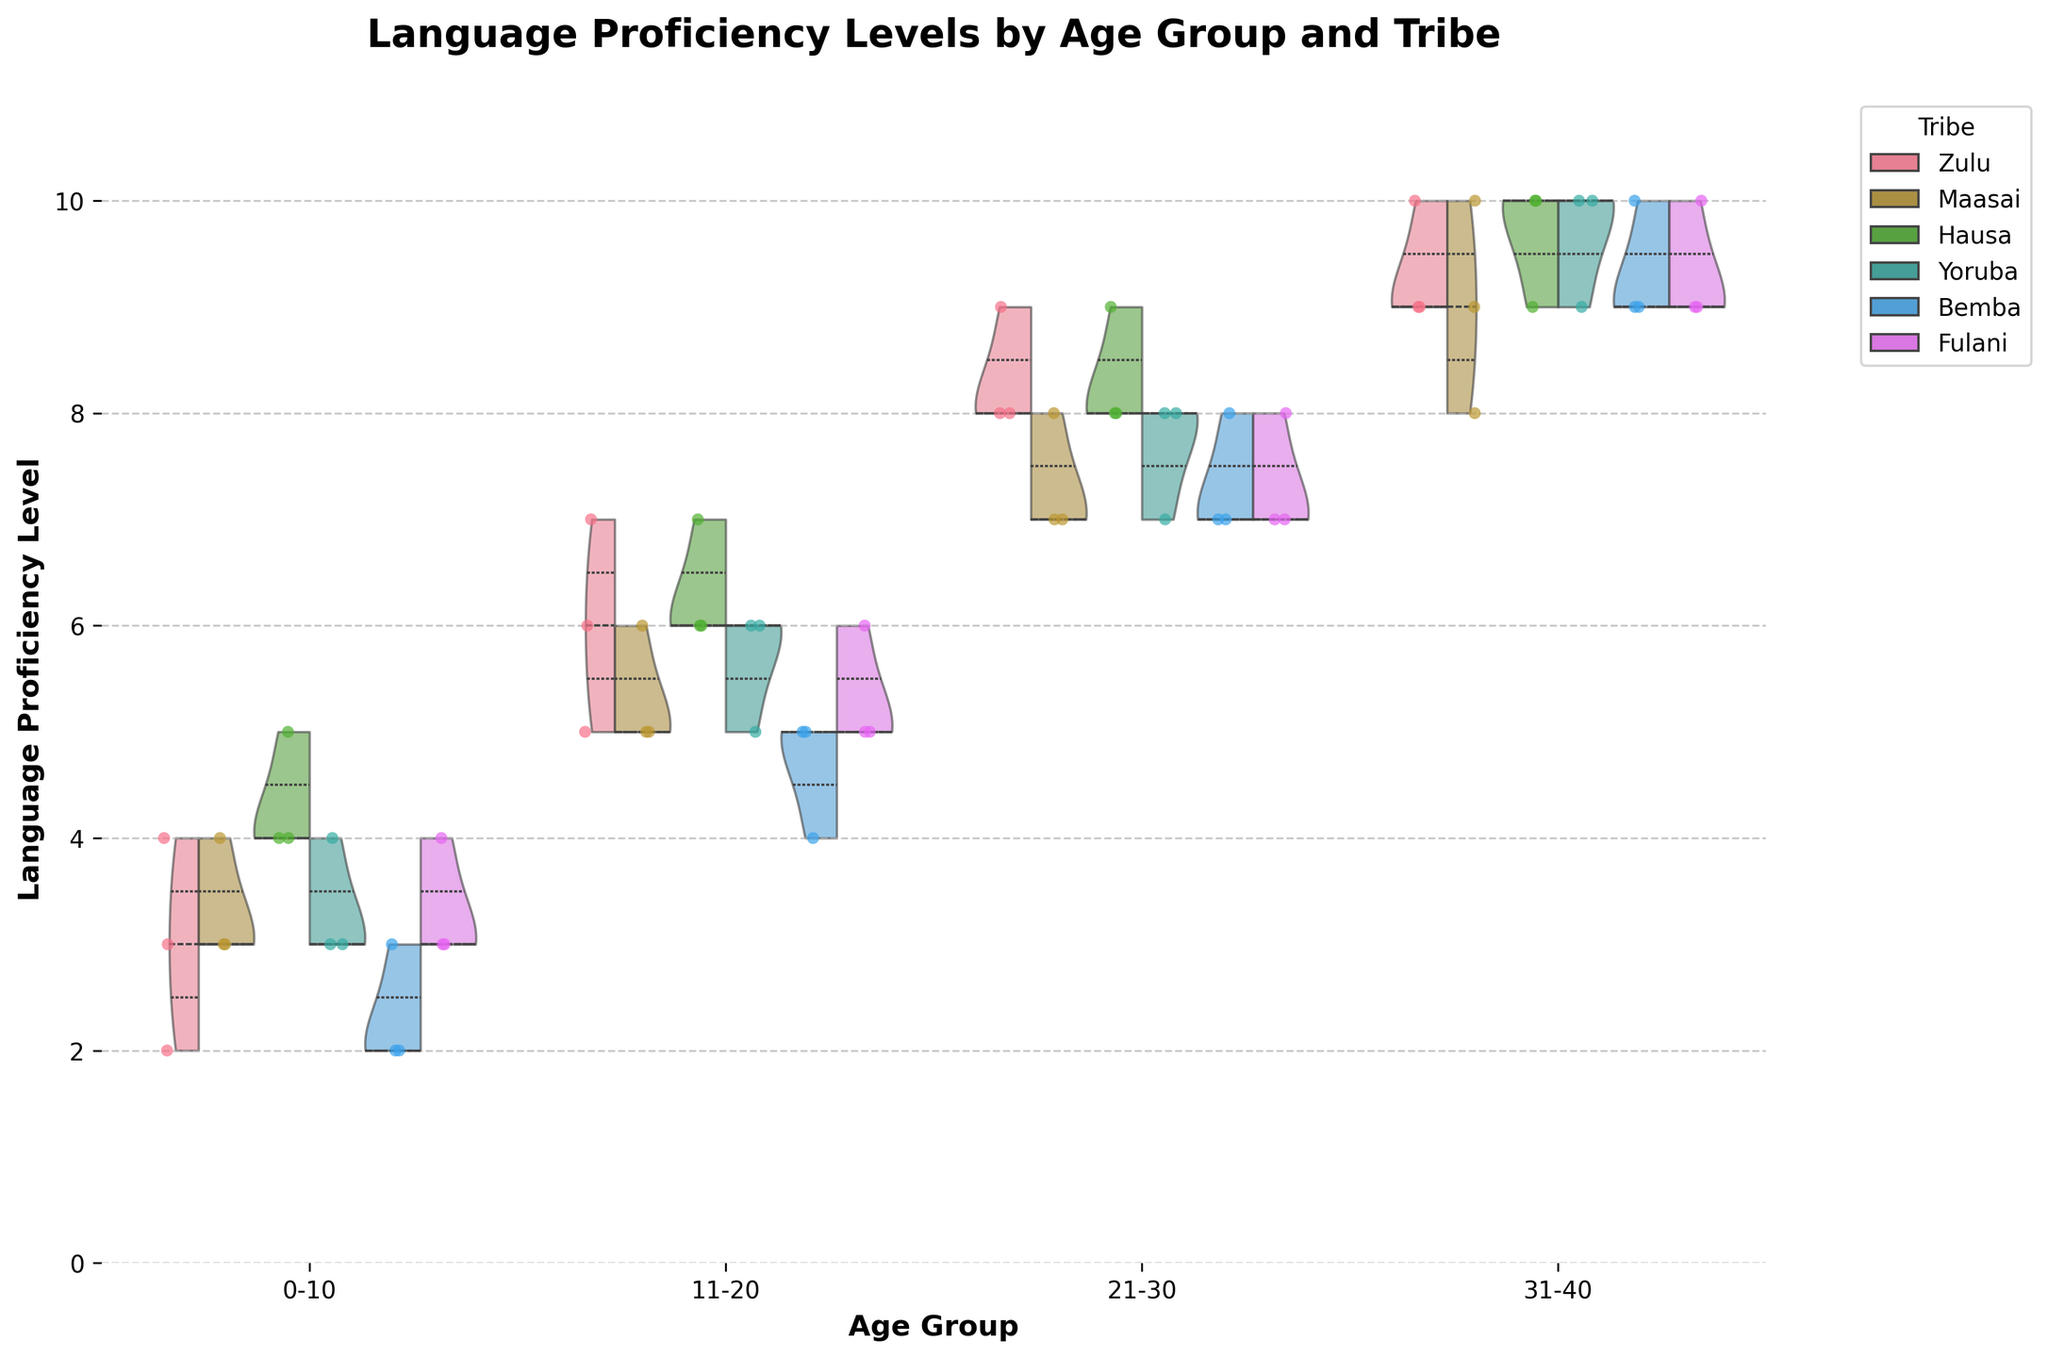What is the highest language proficiency level for the Zulu tribe in the age group 21-30? The chart shows the distribution of language proficiency levels by age group for each tribe. For the Zulu tribe in the age group 21-30, the highest points reach a proficiency level of 9.
Answer: 9 Which tribe has the lowest language proficiency level in the age group 0-10? By comparing the lowest points in the age group 0-10 for all tribes, we see that the Zulu and Bemba tribes both have the lowest language proficiency levels at 2.
Answer: Zulu and Bemba How does the median language proficiency level for the Maasai tribe in the age group 31-40 compare to that of the Hausa tribe in the same age group? Looking at the violin plot, we can see the median lines for both tribes in this age group. The median for the Maasai tribe is at 9, while for the Hausa tribe, it is at 10, indicating the Hausa tribe has a higher median language proficiency.
Answer: Hausa tribe's median is higher What is the trend of language proficiency level with age for the Yoruba tribe? Observing the distribution for the Yoruba tribe across all age groups shows a general increase in language proficiency levels as age increases, with levels ranging from around 3-4 in the 0-10 age group to 9-10 in the 31-40 age group.
Answer: Increases with age Does the data suggest any tribe has a similar trend in language proficiency across age groups? By examining the trends for each tribe, the Fulani tribe appears to exhibit a similar increasing trend in language proficiency levels with age, correlating closely with the Yoruba tribe's pattern.
Answer: Fulani Are there any age groups where multiple tribes have overlapping distributions of language proficiency levels? Examining the overlap areas in the violin plots, the age groups 11-20 and 21-30 for most tribes show significant overlap in distributions, suggesting similar proficiency levels across different tribes in these age ranges.
Answer: 11-20 and 21-30 